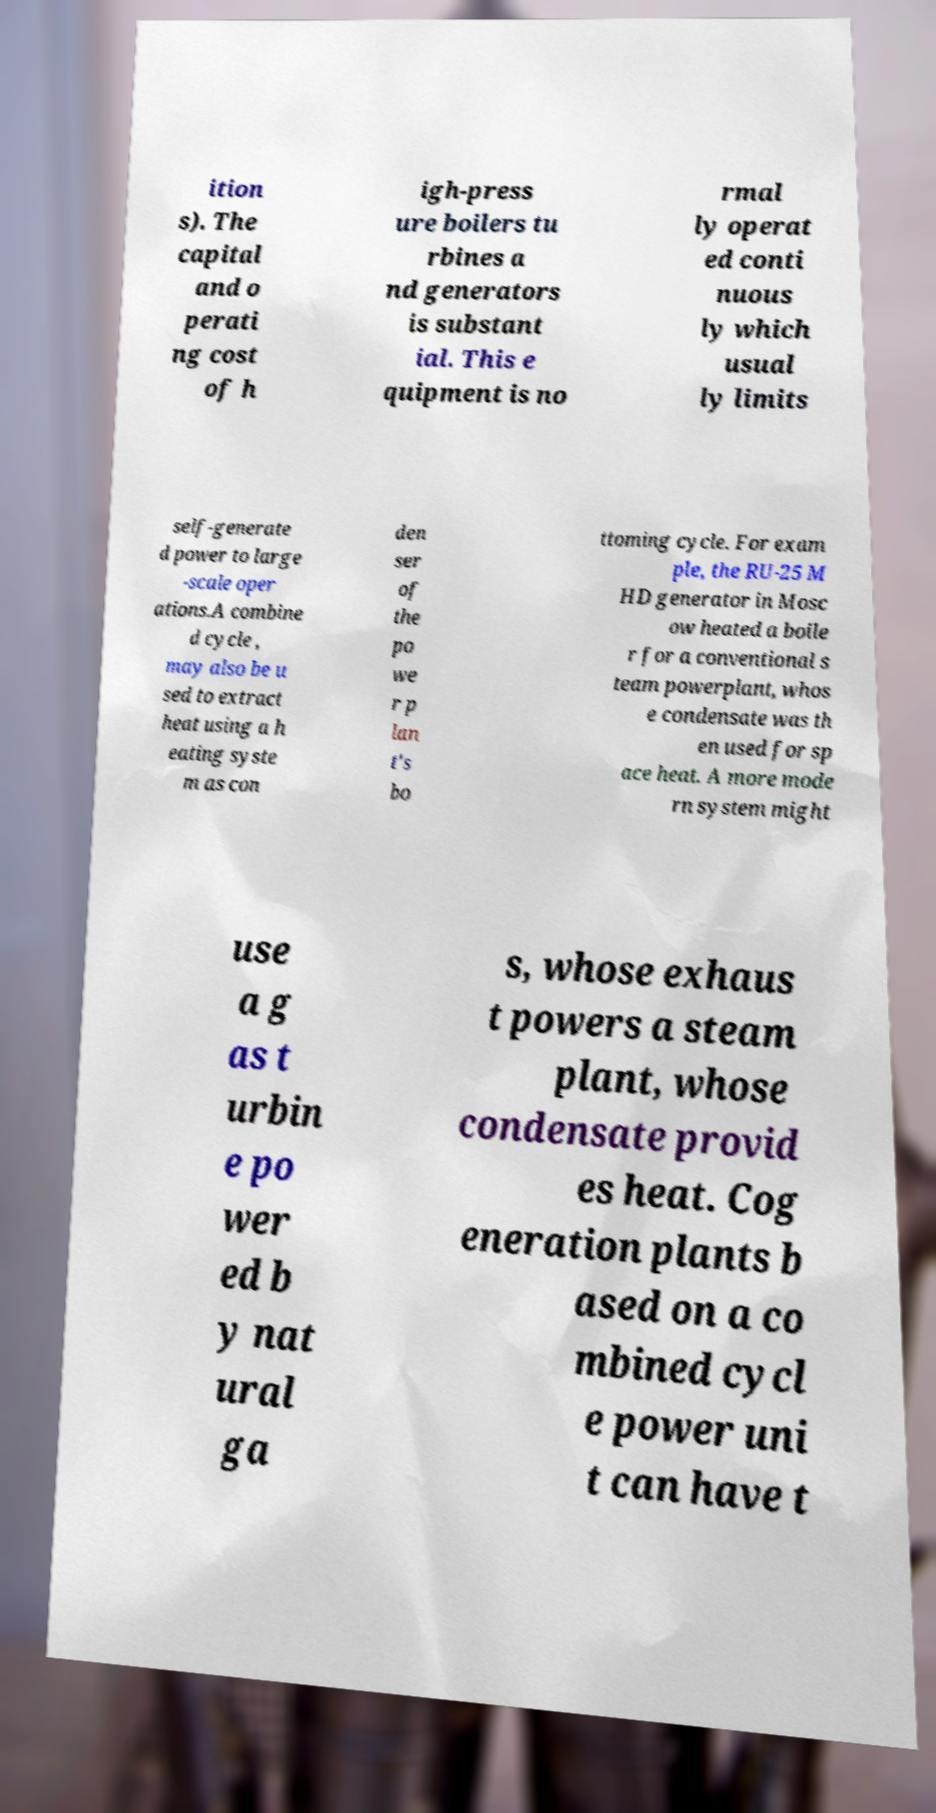Please read and relay the text visible in this image. What does it say? ition s). The capital and o perati ng cost of h igh-press ure boilers tu rbines a nd generators is substant ial. This e quipment is no rmal ly operat ed conti nuous ly which usual ly limits self-generate d power to large -scale oper ations.A combine d cycle , may also be u sed to extract heat using a h eating syste m as con den ser of the po we r p lan t's bo ttoming cycle. For exam ple, the RU-25 M HD generator in Mosc ow heated a boile r for a conventional s team powerplant, whos e condensate was th en used for sp ace heat. A more mode rn system might use a g as t urbin e po wer ed b y nat ural ga s, whose exhaus t powers a steam plant, whose condensate provid es heat. Cog eneration plants b ased on a co mbined cycl e power uni t can have t 